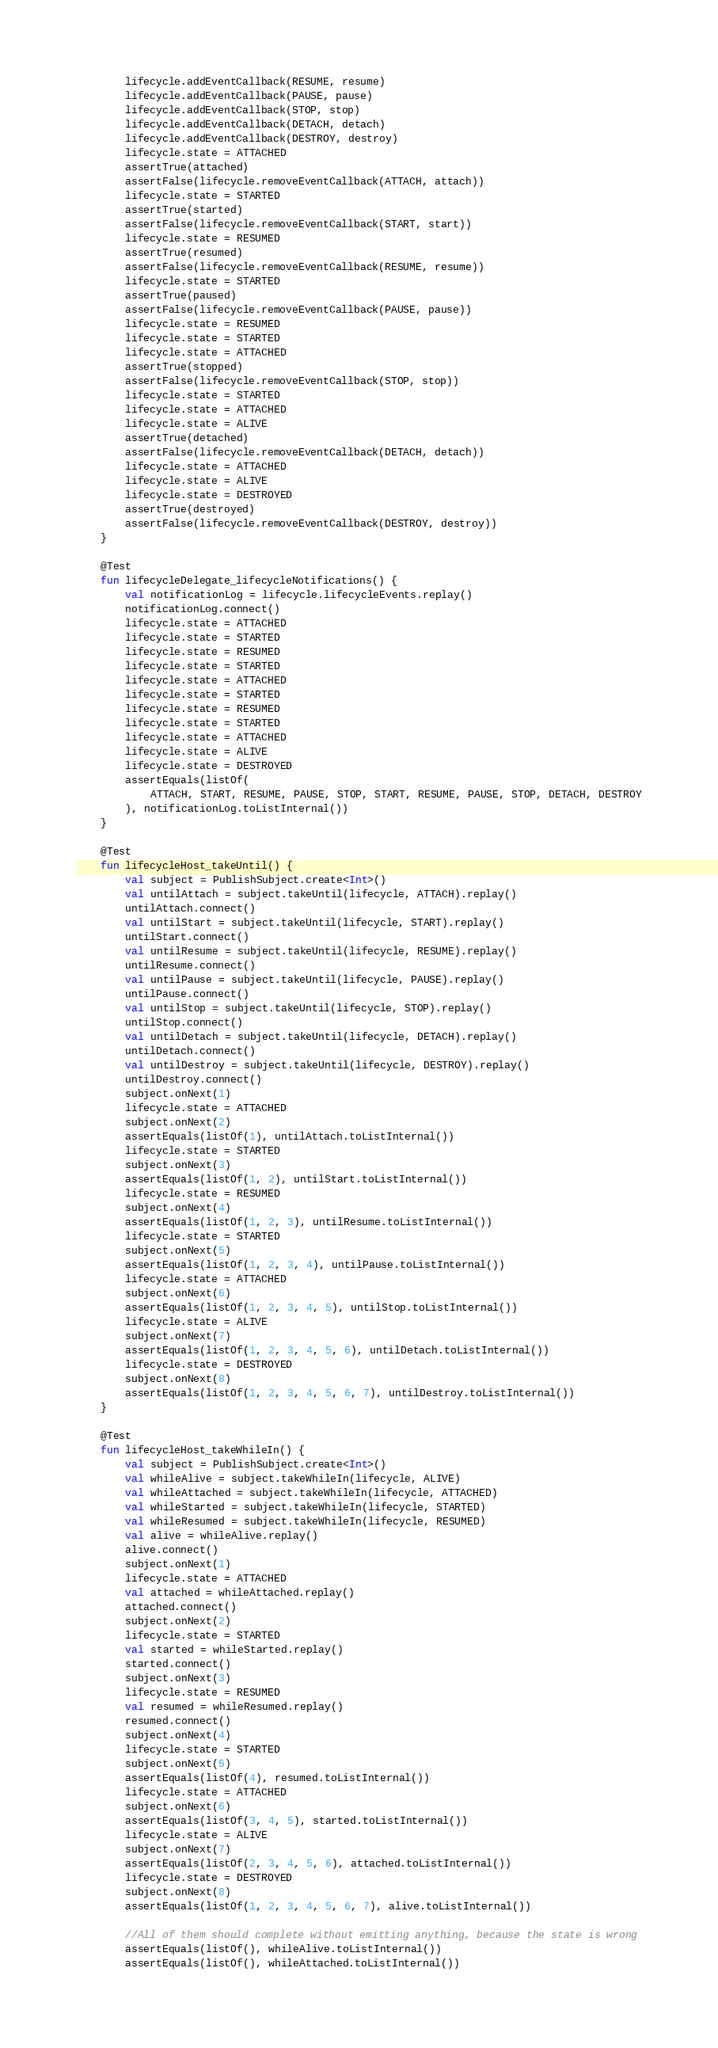<code> <loc_0><loc_0><loc_500><loc_500><_Kotlin_>        lifecycle.addEventCallback(RESUME, resume)
        lifecycle.addEventCallback(PAUSE, pause)
        lifecycle.addEventCallback(STOP, stop)
        lifecycle.addEventCallback(DETACH, detach)
        lifecycle.addEventCallback(DESTROY, destroy)
        lifecycle.state = ATTACHED
        assertTrue(attached)
        assertFalse(lifecycle.removeEventCallback(ATTACH, attach))
        lifecycle.state = STARTED
        assertTrue(started)
        assertFalse(lifecycle.removeEventCallback(START, start))
        lifecycle.state = RESUMED
        assertTrue(resumed)
        assertFalse(lifecycle.removeEventCallback(RESUME, resume))
        lifecycle.state = STARTED
        assertTrue(paused)
        assertFalse(lifecycle.removeEventCallback(PAUSE, pause))
        lifecycle.state = RESUMED
        lifecycle.state = STARTED
        lifecycle.state = ATTACHED
        assertTrue(stopped)
        assertFalse(lifecycle.removeEventCallback(STOP, stop))
        lifecycle.state = STARTED
        lifecycle.state = ATTACHED
        lifecycle.state = ALIVE
        assertTrue(detached)
        assertFalse(lifecycle.removeEventCallback(DETACH, detach))
        lifecycle.state = ATTACHED
        lifecycle.state = ALIVE
        lifecycle.state = DESTROYED
        assertTrue(destroyed)
        assertFalse(lifecycle.removeEventCallback(DESTROY, destroy))
    }

    @Test
    fun lifecycleDelegate_lifecycleNotifications() {
        val notificationLog = lifecycle.lifecycleEvents.replay()
        notificationLog.connect()
        lifecycle.state = ATTACHED
        lifecycle.state = STARTED
        lifecycle.state = RESUMED
        lifecycle.state = STARTED
        lifecycle.state = ATTACHED
        lifecycle.state = STARTED
        lifecycle.state = RESUMED
        lifecycle.state = STARTED
        lifecycle.state = ATTACHED
        lifecycle.state = ALIVE
        lifecycle.state = DESTROYED
        assertEquals(listOf(
            ATTACH, START, RESUME, PAUSE, STOP, START, RESUME, PAUSE, STOP, DETACH, DESTROY
        ), notificationLog.toListInternal())
    }

    @Test
    fun lifecycleHost_takeUntil() {
        val subject = PublishSubject.create<Int>()
        val untilAttach = subject.takeUntil(lifecycle, ATTACH).replay()
        untilAttach.connect()
        val untilStart = subject.takeUntil(lifecycle, START).replay()
        untilStart.connect()
        val untilResume = subject.takeUntil(lifecycle, RESUME).replay()
        untilResume.connect()
        val untilPause = subject.takeUntil(lifecycle, PAUSE).replay()
        untilPause.connect()
        val untilStop = subject.takeUntil(lifecycle, STOP).replay()
        untilStop.connect()
        val untilDetach = subject.takeUntil(lifecycle, DETACH).replay()
        untilDetach.connect()
        val untilDestroy = subject.takeUntil(lifecycle, DESTROY).replay()
        untilDestroy.connect()
        subject.onNext(1)
        lifecycle.state = ATTACHED
        subject.onNext(2)
        assertEquals(listOf(1), untilAttach.toListInternal())
        lifecycle.state = STARTED
        subject.onNext(3)
        assertEquals(listOf(1, 2), untilStart.toListInternal())
        lifecycle.state = RESUMED
        subject.onNext(4)
        assertEquals(listOf(1, 2, 3), untilResume.toListInternal())
        lifecycle.state = STARTED
        subject.onNext(5)
        assertEquals(listOf(1, 2, 3, 4), untilPause.toListInternal())
        lifecycle.state = ATTACHED
        subject.onNext(6)
        assertEquals(listOf(1, 2, 3, 4, 5), untilStop.toListInternal())
        lifecycle.state = ALIVE
        subject.onNext(7)
        assertEquals(listOf(1, 2, 3, 4, 5, 6), untilDetach.toListInternal())
        lifecycle.state = DESTROYED
        subject.onNext(8)
        assertEquals(listOf(1, 2, 3, 4, 5, 6, 7), untilDestroy.toListInternal())
    }

    @Test
    fun lifecycleHost_takeWhileIn() {
        val subject = PublishSubject.create<Int>()
        val whileAlive = subject.takeWhileIn(lifecycle, ALIVE)
        val whileAttached = subject.takeWhileIn(lifecycle, ATTACHED)
        val whileStarted = subject.takeWhileIn(lifecycle, STARTED)
        val whileResumed = subject.takeWhileIn(lifecycle, RESUMED)
        val alive = whileAlive.replay()
        alive.connect()
        subject.onNext(1)
        lifecycle.state = ATTACHED
        val attached = whileAttached.replay()
        attached.connect()
        subject.onNext(2)
        lifecycle.state = STARTED
        val started = whileStarted.replay()
        started.connect()
        subject.onNext(3)
        lifecycle.state = RESUMED
        val resumed = whileResumed.replay()
        resumed.connect()
        subject.onNext(4)
        lifecycle.state = STARTED
        subject.onNext(5)
        assertEquals(listOf(4), resumed.toListInternal())
        lifecycle.state = ATTACHED
        subject.onNext(6)
        assertEquals(listOf(3, 4, 5), started.toListInternal())
        lifecycle.state = ALIVE
        subject.onNext(7)
        assertEquals(listOf(2, 3, 4, 5, 6), attached.toListInternal())
        lifecycle.state = DESTROYED
        subject.onNext(8)
        assertEquals(listOf(1, 2, 3, 4, 5, 6, 7), alive.toListInternal())

        //All of them should complete without emitting anything, because the state is wrong
        assertEquals(listOf(), whileAlive.toListInternal())
        assertEquals(listOf(), whileAttached.toListInternal())</code> 